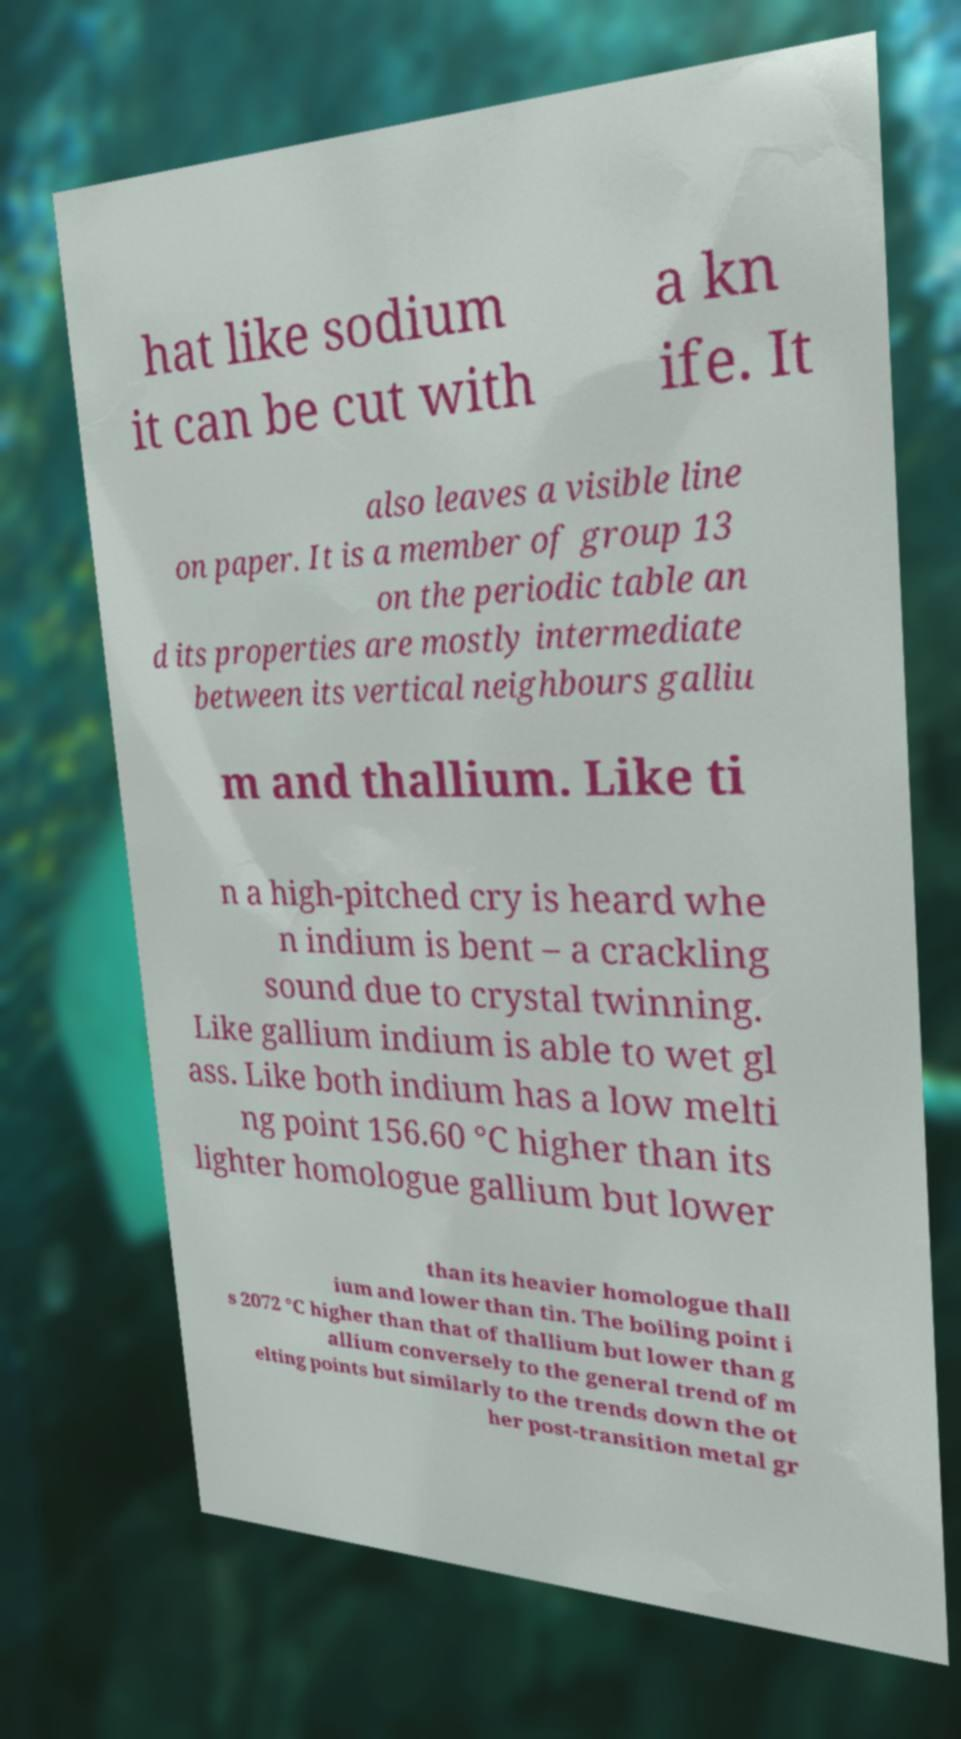Could you assist in decoding the text presented in this image and type it out clearly? hat like sodium it can be cut with a kn ife. It also leaves a visible line on paper. It is a member of group 13 on the periodic table an d its properties are mostly intermediate between its vertical neighbours galliu m and thallium. Like ti n a high-pitched cry is heard whe n indium is bent – a crackling sound due to crystal twinning. Like gallium indium is able to wet gl ass. Like both indium has a low melti ng point 156.60 °C higher than its lighter homologue gallium but lower than its heavier homologue thall ium and lower than tin. The boiling point i s 2072 °C higher than that of thallium but lower than g allium conversely to the general trend of m elting points but similarly to the trends down the ot her post-transition metal gr 